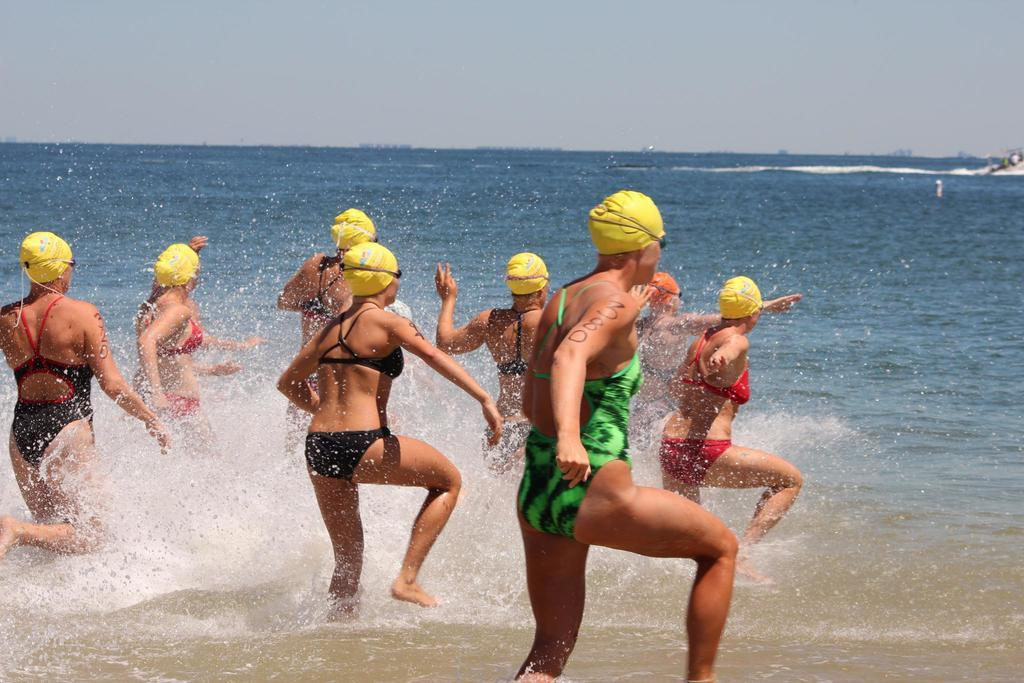What is happening to the humans in the image? The humans are getting into the water in the image. What are the humans wearing on their heads? The humans are wearing caps on their heads. What can be seen in the background of the image? The sky is visible in the image. How would you describe the weather based on the sky in the image? The sky appears to be cloudy in the image. What type of reward is being given to the humans in the image? There is no reward being given to the humans in the image; they are simply getting into the water. Can you see a gate in the image? There is no gate present in the image. 